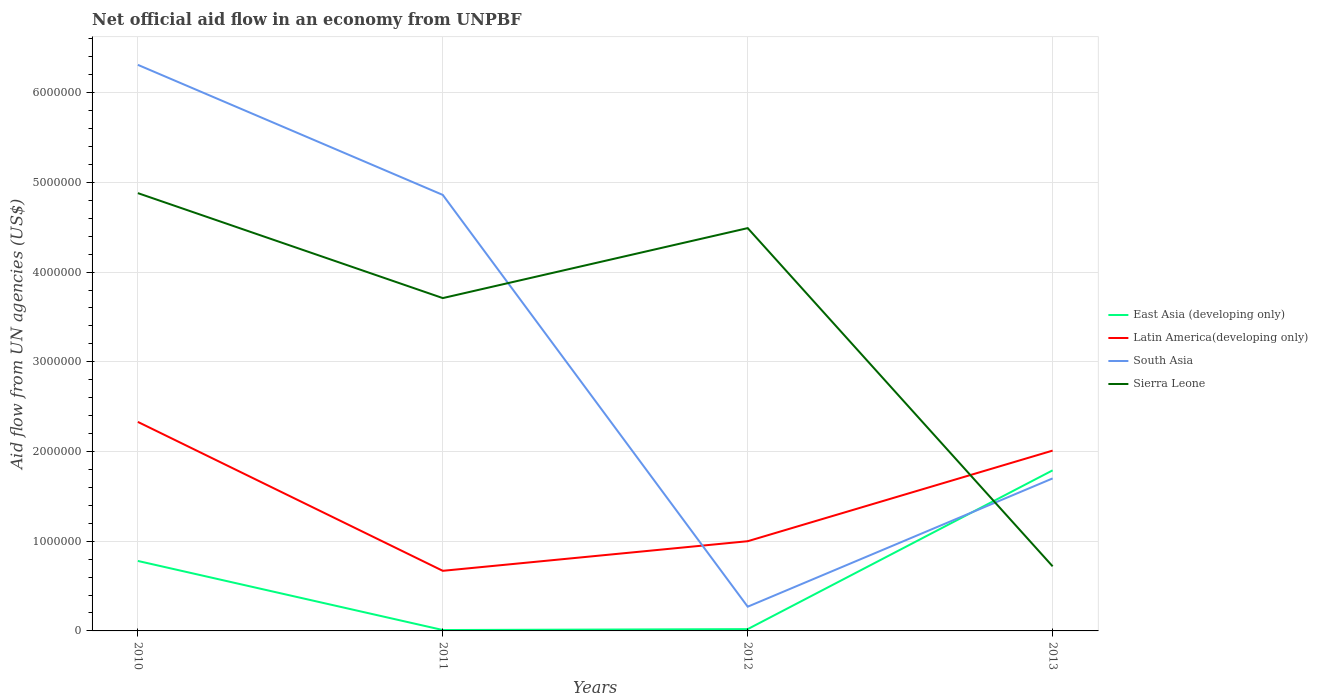How many different coloured lines are there?
Your answer should be very brief. 4. Is the number of lines equal to the number of legend labels?
Ensure brevity in your answer.  Yes. Across all years, what is the maximum net official aid flow in Sierra Leone?
Make the answer very short. 7.20e+05. What is the total net official aid flow in East Asia (developing only) in the graph?
Your answer should be compact. -1.78e+06. What is the difference between the highest and the second highest net official aid flow in East Asia (developing only)?
Keep it short and to the point. 1.78e+06. What is the difference between the highest and the lowest net official aid flow in Latin America(developing only)?
Provide a succinct answer. 2. Does the graph contain grids?
Your answer should be compact. Yes. How many legend labels are there?
Offer a very short reply. 4. What is the title of the graph?
Offer a very short reply. Net official aid flow in an economy from UNPBF. Does "Botswana" appear as one of the legend labels in the graph?
Give a very brief answer. No. What is the label or title of the Y-axis?
Provide a short and direct response. Aid flow from UN agencies (US$). What is the Aid flow from UN agencies (US$) in East Asia (developing only) in 2010?
Ensure brevity in your answer.  7.80e+05. What is the Aid flow from UN agencies (US$) in Latin America(developing only) in 2010?
Your response must be concise. 2.33e+06. What is the Aid flow from UN agencies (US$) of South Asia in 2010?
Offer a terse response. 6.31e+06. What is the Aid flow from UN agencies (US$) in Sierra Leone in 2010?
Provide a succinct answer. 4.88e+06. What is the Aid flow from UN agencies (US$) of Latin America(developing only) in 2011?
Your answer should be compact. 6.70e+05. What is the Aid flow from UN agencies (US$) of South Asia in 2011?
Ensure brevity in your answer.  4.86e+06. What is the Aid flow from UN agencies (US$) in Sierra Leone in 2011?
Keep it short and to the point. 3.71e+06. What is the Aid flow from UN agencies (US$) in East Asia (developing only) in 2012?
Make the answer very short. 2.00e+04. What is the Aid flow from UN agencies (US$) of Latin America(developing only) in 2012?
Your response must be concise. 1.00e+06. What is the Aid flow from UN agencies (US$) in South Asia in 2012?
Make the answer very short. 2.70e+05. What is the Aid flow from UN agencies (US$) in Sierra Leone in 2012?
Your answer should be compact. 4.49e+06. What is the Aid flow from UN agencies (US$) of East Asia (developing only) in 2013?
Provide a short and direct response. 1.79e+06. What is the Aid flow from UN agencies (US$) of Latin America(developing only) in 2013?
Make the answer very short. 2.01e+06. What is the Aid flow from UN agencies (US$) in South Asia in 2013?
Your answer should be very brief. 1.70e+06. What is the Aid flow from UN agencies (US$) in Sierra Leone in 2013?
Keep it short and to the point. 7.20e+05. Across all years, what is the maximum Aid flow from UN agencies (US$) in East Asia (developing only)?
Your response must be concise. 1.79e+06. Across all years, what is the maximum Aid flow from UN agencies (US$) of Latin America(developing only)?
Offer a very short reply. 2.33e+06. Across all years, what is the maximum Aid flow from UN agencies (US$) in South Asia?
Make the answer very short. 6.31e+06. Across all years, what is the maximum Aid flow from UN agencies (US$) of Sierra Leone?
Your answer should be very brief. 4.88e+06. Across all years, what is the minimum Aid flow from UN agencies (US$) in East Asia (developing only)?
Keep it short and to the point. 10000. Across all years, what is the minimum Aid flow from UN agencies (US$) in Latin America(developing only)?
Offer a very short reply. 6.70e+05. Across all years, what is the minimum Aid flow from UN agencies (US$) of South Asia?
Make the answer very short. 2.70e+05. Across all years, what is the minimum Aid flow from UN agencies (US$) in Sierra Leone?
Offer a terse response. 7.20e+05. What is the total Aid flow from UN agencies (US$) of East Asia (developing only) in the graph?
Your response must be concise. 2.60e+06. What is the total Aid flow from UN agencies (US$) in Latin America(developing only) in the graph?
Keep it short and to the point. 6.01e+06. What is the total Aid flow from UN agencies (US$) of South Asia in the graph?
Keep it short and to the point. 1.31e+07. What is the total Aid flow from UN agencies (US$) in Sierra Leone in the graph?
Offer a terse response. 1.38e+07. What is the difference between the Aid flow from UN agencies (US$) of East Asia (developing only) in 2010 and that in 2011?
Your response must be concise. 7.70e+05. What is the difference between the Aid flow from UN agencies (US$) of Latin America(developing only) in 2010 and that in 2011?
Your answer should be very brief. 1.66e+06. What is the difference between the Aid flow from UN agencies (US$) of South Asia in 2010 and that in 2011?
Give a very brief answer. 1.45e+06. What is the difference between the Aid flow from UN agencies (US$) of Sierra Leone in 2010 and that in 2011?
Offer a terse response. 1.17e+06. What is the difference between the Aid flow from UN agencies (US$) in East Asia (developing only) in 2010 and that in 2012?
Provide a succinct answer. 7.60e+05. What is the difference between the Aid flow from UN agencies (US$) in Latin America(developing only) in 2010 and that in 2012?
Ensure brevity in your answer.  1.33e+06. What is the difference between the Aid flow from UN agencies (US$) in South Asia in 2010 and that in 2012?
Keep it short and to the point. 6.04e+06. What is the difference between the Aid flow from UN agencies (US$) of East Asia (developing only) in 2010 and that in 2013?
Provide a succinct answer. -1.01e+06. What is the difference between the Aid flow from UN agencies (US$) of South Asia in 2010 and that in 2013?
Your response must be concise. 4.61e+06. What is the difference between the Aid flow from UN agencies (US$) of Sierra Leone in 2010 and that in 2013?
Offer a terse response. 4.16e+06. What is the difference between the Aid flow from UN agencies (US$) in East Asia (developing only) in 2011 and that in 2012?
Ensure brevity in your answer.  -10000. What is the difference between the Aid flow from UN agencies (US$) in Latin America(developing only) in 2011 and that in 2012?
Your response must be concise. -3.30e+05. What is the difference between the Aid flow from UN agencies (US$) in South Asia in 2011 and that in 2012?
Provide a short and direct response. 4.59e+06. What is the difference between the Aid flow from UN agencies (US$) in Sierra Leone in 2011 and that in 2012?
Your answer should be very brief. -7.80e+05. What is the difference between the Aid flow from UN agencies (US$) in East Asia (developing only) in 2011 and that in 2013?
Offer a very short reply. -1.78e+06. What is the difference between the Aid flow from UN agencies (US$) in Latin America(developing only) in 2011 and that in 2013?
Give a very brief answer. -1.34e+06. What is the difference between the Aid flow from UN agencies (US$) in South Asia in 2011 and that in 2013?
Provide a succinct answer. 3.16e+06. What is the difference between the Aid flow from UN agencies (US$) in Sierra Leone in 2011 and that in 2013?
Keep it short and to the point. 2.99e+06. What is the difference between the Aid flow from UN agencies (US$) in East Asia (developing only) in 2012 and that in 2013?
Provide a succinct answer. -1.77e+06. What is the difference between the Aid flow from UN agencies (US$) in Latin America(developing only) in 2012 and that in 2013?
Ensure brevity in your answer.  -1.01e+06. What is the difference between the Aid flow from UN agencies (US$) of South Asia in 2012 and that in 2013?
Keep it short and to the point. -1.43e+06. What is the difference between the Aid flow from UN agencies (US$) in Sierra Leone in 2012 and that in 2013?
Give a very brief answer. 3.77e+06. What is the difference between the Aid flow from UN agencies (US$) of East Asia (developing only) in 2010 and the Aid flow from UN agencies (US$) of South Asia in 2011?
Ensure brevity in your answer.  -4.08e+06. What is the difference between the Aid flow from UN agencies (US$) of East Asia (developing only) in 2010 and the Aid flow from UN agencies (US$) of Sierra Leone in 2011?
Your answer should be compact. -2.93e+06. What is the difference between the Aid flow from UN agencies (US$) of Latin America(developing only) in 2010 and the Aid flow from UN agencies (US$) of South Asia in 2011?
Provide a succinct answer. -2.53e+06. What is the difference between the Aid flow from UN agencies (US$) in Latin America(developing only) in 2010 and the Aid flow from UN agencies (US$) in Sierra Leone in 2011?
Provide a short and direct response. -1.38e+06. What is the difference between the Aid flow from UN agencies (US$) in South Asia in 2010 and the Aid flow from UN agencies (US$) in Sierra Leone in 2011?
Make the answer very short. 2.60e+06. What is the difference between the Aid flow from UN agencies (US$) in East Asia (developing only) in 2010 and the Aid flow from UN agencies (US$) in South Asia in 2012?
Your answer should be compact. 5.10e+05. What is the difference between the Aid flow from UN agencies (US$) of East Asia (developing only) in 2010 and the Aid flow from UN agencies (US$) of Sierra Leone in 2012?
Your answer should be compact. -3.71e+06. What is the difference between the Aid flow from UN agencies (US$) of Latin America(developing only) in 2010 and the Aid flow from UN agencies (US$) of South Asia in 2012?
Make the answer very short. 2.06e+06. What is the difference between the Aid flow from UN agencies (US$) of Latin America(developing only) in 2010 and the Aid flow from UN agencies (US$) of Sierra Leone in 2012?
Make the answer very short. -2.16e+06. What is the difference between the Aid flow from UN agencies (US$) of South Asia in 2010 and the Aid flow from UN agencies (US$) of Sierra Leone in 2012?
Make the answer very short. 1.82e+06. What is the difference between the Aid flow from UN agencies (US$) of East Asia (developing only) in 2010 and the Aid flow from UN agencies (US$) of Latin America(developing only) in 2013?
Offer a very short reply. -1.23e+06. What is the difference between the Aid flow from UN agencies (US$) in East Asia (developing only) in 2010 and the Aid flow from UN agencies (US$) in South Asia in 2013?
Keep it short and to the point. -9.20e+05. What is the difference between the Aid flow from UN agencies (US$) in East Asia (developing only) in 2010 and the Aid flow from UN agencies (US$) in Sierra Leone in 2013?
Your answer should be compact. 6.00e+04. What is the difference between the Aid flow from UN agencies (US$) in Latin America(developing only) in 2010 and the Aid flow from UN agencies (US$) in South Asia in 2013?
Make the answer very short. 6.30e+05. What is the difference between the Aid flow from UN agencies (US$) in Latin America(developing only) in 2010 and the Aid flow from UN agencies (US$) in Sierra Leone in 2013?
Offer a very short reply. 1.61e+06. What is the difference between the Aid flow from UN agencies (US$) of South Asia in 2010 and the Aid flow from UN agencies (US$) of Sierra Leone in 2013?
Your response must be concise. 5.59e+06. What is the difference between the Aid flow from UN agencies (US$) of East Asia (developing only) in 2011 and the Aid flow from UN agencies (US$) of Latin America(developing only) in 2012?
Give a very brief answer. -9.90e+05. What is the difference between the Aid flow from UN agencies (US$) in East Asia (developing only) in 2011 and the Aid flow from UN agencies (US$) in South Asia in 2012?
Make the answer very short. -2.60e+05. What is the difference between the Aid flow from UN agencies (US$) in East Asia (developing only) in 2011 and the Aid flow from UN agencies (US$) in Sierra Leone in 2012?
Keep it short and to the point. -4.48e+06. What is the difference between the Aid flow from UN agencies (US$) of Latin America(developing only) in 2011 and the Aid flow from UN agencies (US$) of South Asia in 2012?
Ensure brevity in your answer.  4.00e+05. What is the difference between the Aid flow from UN agencies (US$) of Latin America(developing only) in 2011 and the Aid flow from UN agencies (US$) of Sierra Leone in 2012?
Your answer should be compact. -3.82e+06. What is the difference between the Aid flow from UN agencies (US$) of South Asia in 2011 and the Aid flow from UN agencies (US$) of Sierra Leone in 2012?
Ensure brevity in your answer.  3.70e+05. What is the difference between the Aid flow from UN agencies (US$) of East Asia (developing only) in 2011 and the Aid flow from UN agencies (US$) of Latin America(developing only) in 2013?
Offer a very short reply. -2.00e+06. What is the difference between the Aid flow from UN agencies (US$) in East Asia (developing only) in 2011 and the Aid flow from UN agencies (US$) in South Asia in 2013?
Your answer should be very brief. -1.69e+06. What is the difference between the Aid flow from UN agencies (US$) in East Asia (developing only) in 2011 and the Aid flow from UN agencies (US$) in Sierra Leone in 2013?
Ensure brevity in your answer.  -7.10e+05. What is the difference between the Aid flow from UN agencies (US$) of Latin America(developing only) in 2011 and the Aid flow from UN agencies (US$) of South Asia in 2013?
Your answer should be very brief. -1.03e+06. What is the difference between the Aid flow from UN agencies (US$) of South Asia in 2011 and the Aid flow from UN agencies (US$) of Sierra Leone in 2013?
Your response must be concise. 4.14e+06. What is the difference between the Aid flow from UN agencies (US$) in East Asia (developing only) in 2012 and the Aid flow from UN agencies (US$) in Latin America(developing only) in 2013?
Make the answer very short. -1.99e+06. What is the difference between the Aid flow from UN agencies (US$) in East Asia (developing only) in 2012 and the Aid flow from UN agencies (US$) in South Asia in 2013?
Your answer should be very brief. -1.68e+06. What is the difference between the Aid flow from UN agencies (US$) of East Asia (developing only) in 2012 and the Aid flow from UN agencies (US$) of Sierra Leone in 2013?
Provide a short and direct response. -7.00e+05. What is the difference between the Aid flow from UN agencies (US$) of Latin America(developing only) in 2012 and the Aid flow from UN agencies (US$) of South Asia in 2013?
Offer a very short reply. -7.00e+05. What is the difference between the Aid flow from UN agencies (US$) in Latin America(developing only) in 2012 and the Aid flow from UN agencies (US$) in Sierra Leone in 2013?
Ensure brevity in your answer.  2.80e+05. What is the difference between the Aid flow from UN agencies (US$) in South Asia in 2012 and the Aid flow from UN agencies (US$) in Sierra Leone in 2013?
Give a very brief answer. -4.50e+05. What is the average Aid flow from UN agencies (US$) of East Asia (developing only) per year?
Your response must be concise. 6.50e+05. What is the average Aid flow from UN agencies (US$) of Latin America(developing only) per year?
Your answer should be compact. 1.50e+06. What is the average Aid flow from UN agencies (US$) of South Asia per year?
Offer a very short reply. 3.28e+06. What is the average Aid flow from UN agencies (US$) of Sierra Leone per year?
Provide a short and direct response. 3.45e+06. In the year 2010, what is the difference between the Aid flow from UN agencies (US$) of East Asia (developing only) and Aid flow from UN agencies (US$) of Latin America(developing only)?
Provide a short and direct response. -1.55e+06. In the year 2010, what is the difference between the Aid flow from UN agencies (US$) in East Asia (developing only) and Aid flow from UN agencies (US$) in South Asia?
Keep it short and to the point. -5.53e+06. In the year 2010, what is the difference between the Aid flow from UN agencies (US$) of East Asia (developing only) and Aid flow from UN agencies (US$) of Sierra Leone?
Offer a terse response. -4.10e+06. In the year 2010, what is the difference between the Aid flow from UN agencies (US$) in Latin America(developing only) and Aid flow from UN agencies (US$) in South Asia?
Offer a very short reply. -3.98e+06. In the year 2010, what is the difference between the Aid flow from UN agencies (US$) in Latin America(developing only) and Aid flow from UN agencies (US$) in Sierra Leone?
Your answer should be compact. -2.55e+06. In the year 2010, what is the difference between the Aid flow from UN agencies (US$) of South Asia and Aid flow from UN agencies (US$) of Sierra Leone?
Offer a terse response. 1.43e+06. In the year 2011, what is the difference between the Aid flow from UN agencies (US$) in East Asia (developing only) and Aid flow from UN agencies (US$) in Latin America(developing only)?
Your response must be concise. -6.60e+05. In the year 2011, what is the difference between the Aid flow from UN agencies (US$) of East Asia (developing only) and Aid flow from UN agencies (US$) of South Asia?
Offer a very short reply. -4.85e+06. In the year 2011, what is the difference between the Aid flow from UN agencies (US$) of East Asia (developing only) and Aid flow from UN agencies (US$) of Sierra Leone?
Provide a succinct answer. -3.70e+06. In the year 2011, what is the difference between the Aid flow from UN agencies (US$) in Latin America(developing only) and Aid flow from UN agencies (US$) in South Asia?
Provide a short and direct response. -4.19e+06. In the year 2011, what is the difference between the Aid flow from UN agencies (US$) in Latin America(developing only) and Aid flow from UN agencies (US$) in Sierra Leone?
Provide a short and direct response. -3.04e+06. In the year 2011, what is the difference between the Aid flow from UN agencies (US$) of South Asia and Aid flow from UN agencies (US$) of Sierra Leone?
Offer a terse response. 1.15e+06. In the year 2012, what is the difference between the Aid flow from UN agencies (US$) of East Asia (developing only) and Aid flow from UN agencies (US$) of Latin America(developing only)?
Your response must be concise. -9.80e+05. In the year 2012, what is the difference between the Aid flow from UN agencies (US$) in East Asia (developing only) and Aid flow from UN agencies (US$) in South Asia?
Ensure brevity in your answer.  -2.50e+05. In the year 2012, what is the difference between the Aid flow from UN agencies (US$) of East Asia (developing only) and Aid flow from UN agencies (US$) of Sierra Leone?
Offer a terse response. -4.47e+06. In the year 2012, what is the difference between the Aid flow from UN agencies (US$) in Latin America(developing only) and Aid flow from UN agencies (US$) in South Asia?
Provide a succinct answer. 7.30e+05. In the year 2012, what is the difference between the Aid flow from UN agencies (US$) of Latin America(developing only) and Aid flow from UN agencies (US$) of Sierra Leone?
Your response must be concise. -3.49e+06. In the year 2012, what is the difference between the Aid flow from UN agencies (US$) of South Asia and Aid flow from UN agencies (US$) of Sierra Leone?
Make the answer very short. -4.22e+06. In the year 2013, what is the difference between the Aid flow from UN agencies (US$) of East Asia (developing only) and Aid flow from UN agencies (US$) of Latin America(developing only)?
Keep it short and to the point. -2.20e+05. In the year 2013, what is the difference between the Aid flow from UN agencies (US$) in East Asia (developing only) and Aid flow from UN agencies (US$) in South Asia?
Keep it short and to the point. 9.00e+04. In the year 2013, what is the difference between the Aid flow from UN agencies (US$) of East Asia (developing only) and Aid flow from UN agencies (US$) of Sierra Leone?
Your response must be concise. 1.07e+06. In the year 2013, what is the difference between the Aid flow from UN agencies (US$) in Latin America(developing only) and Aid flow from UN agencies (US$) in South Asia?
Ensure brevity in your answer.  3.10e+05. In the year 2013, what is the difference between the Aid flow from UN agencies (US$) of Latin America(developing only) and Aid flow from UN agencies (US$) of Sierra Leone?
Give a very brief answer. 1.29e+06. In the year 2013, what is the difference between the Aid flow from UN agencies (US$) of South Asia and Aid flow from UN agencies (US$) of Sierra Leone?
Your answer should be compact. 9.80e+05. What is the ratio of the Aid flow from UN agencies (US$) of East Asia (developing only) in 2010 to that in 2011?
Offer a terse response. 78. What is the ratio of the Aid flow from UN agencies (US$) in Latin America(developing only) in 2010 to that in 2011?
Make the answer very short. 3.48. What is the ratio of the Aid flow from UN agencies (US$) in South Asia in 2010 to that in 2011?
Give a very brief answer. 1.3. What is the ratio of the Aid flow from UN agencies (US$) in Sierra Leone in 2010 to that in 2011?
Your response must be concise. 1.32. What is the ratio of the Aid flow from UN agencies (US$) of East Asia (developing only) in 2010 to that in 2012?
Offer a very short reply. 39. What is the ratio of the Aid flow from UN agencies (US$) of Latin America(developing only) in 2010 to that in 2012?
Your answer should be compact. 2.33. What is the ratio of the Aid flow from UN agencies (US$) of South Asia in 2010 to that in 2012?
Keep it short and to the point. 23.37. What is the ratio of the Aid flow from UN agencies (US$) of Sierra Leone in 2010 to that in 2012?
Your answer should be very brief. 1.09. What is the ratio of the Aid flow from UN agencies (US$) in East Asia (developing only) in 2010 to that in 2013?
Keep it short and to the point. 0.44. What is the ratio of the Aid flow from UN agencies (US$) in Latin America(developing only) in 2010 to that in 2013?
Give a very brief answer. 1.16. What is the ratio of the Aid flow from UN agencies (US$) in South Asia in 2010 to that in 2013?
Provide a succinct answer. 3.71. What is the ratio of the Aid flow from UN agencies (US$) of Sierra Leone in 2010 to that in 2013?
Offer a terse response. 6.78. What is the ratio of the Aid flow from UN agencies (US$) of East Asia (developing only) in 2011 to that in 2012?
Ensure brevity in your answer.  0.5. What is the ratio of the Aid flow from UN agencies (US$) in Latin America(developing only) in 2011 to that in 2012?
Offer a very short reply. 0.67. What is the ratio of the Aid flow from UN agencies (US$) in South Asia in 2011 to that in 2012?
Ensure brevity in your answer.  18. What is the ratio of the Aid flow from UN agencies (US$) of Sierra Leone in 2011 to that in 2012?
Your answer should be very brief. 0.83. What is the ratio of the Aid flow from UN agencies (US$) in East Asia (developing only) in 2011 to that in 2013?
Offer a terse response. 0.01. What is the ratio of the Aid flow from UN agencies (US$) of South Asia in 2011 to that in 2013?
Your answer should be very brief. 2.86. What is the ratio of the Aid flow from UN agencies (US$) of Sierra Leone in 2011 to that in 2013?
Your response must be concise. 5.15. What is the ratio of the Aid flow from UN agencies (US$) in East Asia (developing only) in 2012 to that in 2013?
Make the answer very short. 0.01. What is the ratio of the Aid flow from UN agencies (US$) in Latin America(developing only) in 2012 to that in 2013?
Provide a short and direct response. 0.5. What is the ratio of the Aid flow from UN agencies (US$) of South Asia in 2012 to that in 2013?
Give a very brief answer. 0.16. What is the ratio of the Aid flow from UN agencies (US$) of Sierra Leone in 2012 to that in 2013?
Your answer should be compact. 6.24. What is the difference between the highest and the second highest Aid flow from UN agencies (US$) of East Asia (developing only)?
Offer a very short reply. 1.01e+06. What is the difference between the highest and the second highest Aid flow from UN agencies (US$) of South Asia?
Provide a succinct answer. 1.45e+06. What is the difference between the highest and the second highest Aid flow from UN agencies (US$) in Sierra Leone?
Give a very brief answer. 3.90e+05. What is the difference between the highest and the lowest Aid flow from UN agencies (US$) in East Asia (developing only)?
Make the answer very short. 1.78e+06. What is the difference between the highest and the lowest Aid flow from UN agencies (US$) of Latin America(developing only)?
Keep it short and to the point. 1.66e+06. What is the difference between the highest and the lowest Aid flow from UN agencies (US$) in South Asia?
Your answer should be compact. 6.04e+06. What is the difference between the highest and the lowest Aid flow from UN agencies (US$) of Sierra Leone?
Ensure brevity in your answer.  4.16e+06. 